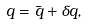<formula> <loc_0><loc_0><loc_500><loc_500>q = \bar { q } + \delta q ,</formula> 